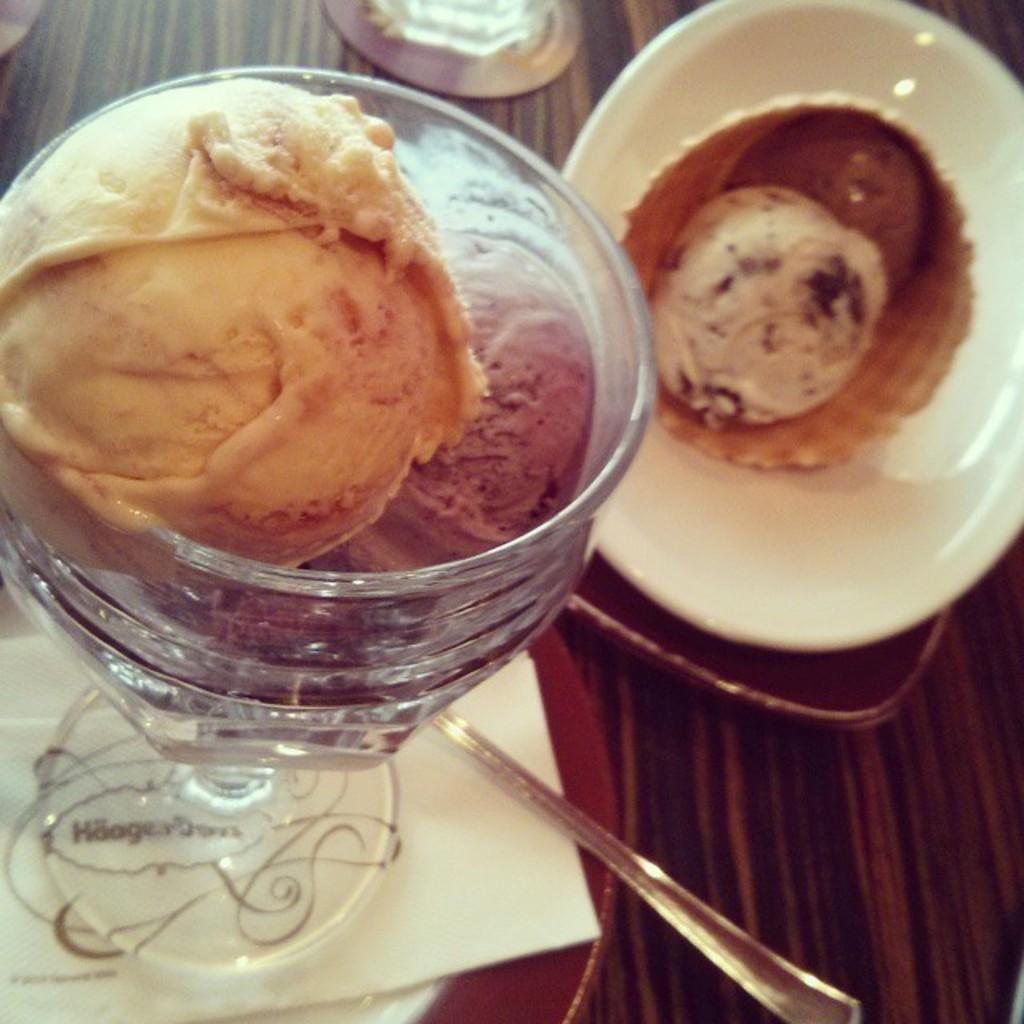How would you summarize this image in a sentence or two? In this image there is a wooden table. On the wooden table there are plates. To the right there is a waffle on the plate. To the left there is a cup. Below the cup there is a tissue paper. In the cup there is ice cream Beside the cup there is a spoon. 